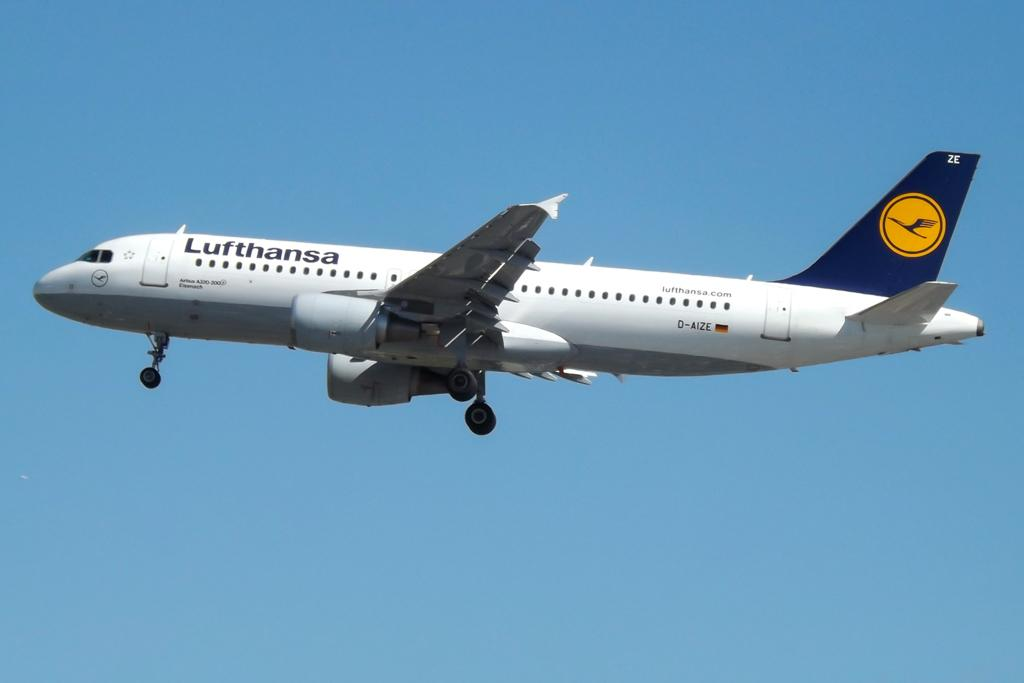<image>
Relay a brief, clear account of the picture shown. A Lufthansa aircraft is flying through a cloudless sky. 